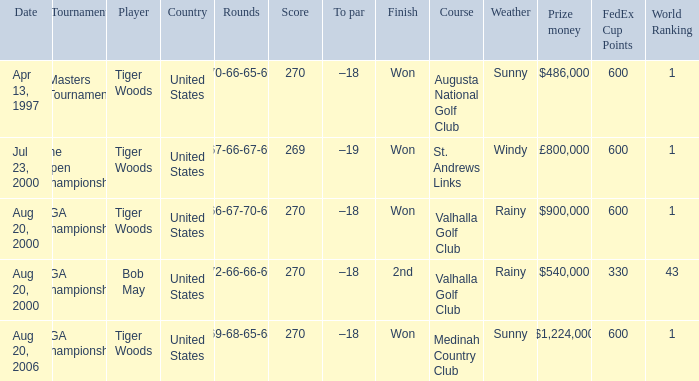What days were the rounds of 66-67-70-67 recorded? Aug 20, 2000. 